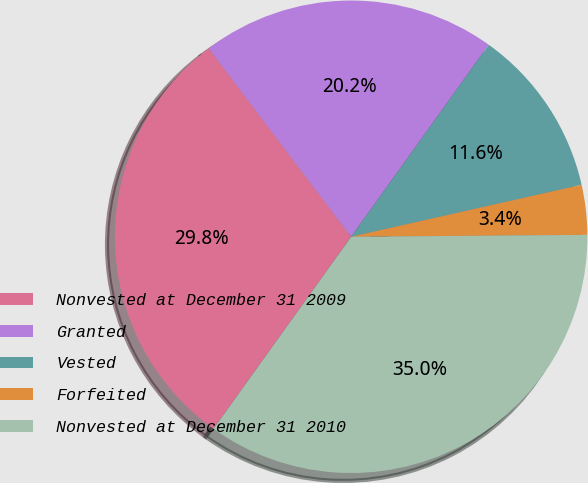Convert chart to OTSL. <chart><loc_0><loc_0><loc_500><loc_500><pie_chart><fcel>Nonvested at December 31 2009<fcel>Granted<fcel>Vested<fcel>Forfeited<fcel>Nonvested at December 31 2010<nl><fcel>29.8%<fcel>20.2%<fcel>11.57%<fcel>3.4%<fcel>35.03%<nl></chart> 